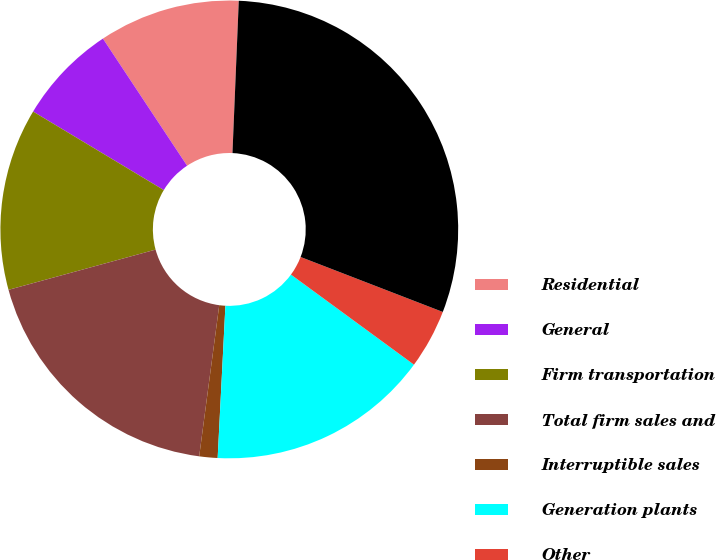Convert chart. <chart><loc_0><loc_0><loc_500><loc_500><pie_chart><fcel>Residential<fcel>General<fcel>Firm transportation<fcel>Total firm sales and<fcel>Interruptible sales<fcel>Generation plants<fcel>Other<fcel>Total<nl><fcel>9.97%<fcel>7.08%<fcel>12.86%<fcel>18.65%<fcel>1.29%<fcel>15.75%<fcel>4.19%<fcel>30.21%<nl></chart> 